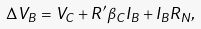Convert formula to latex. <formula><loc_0><loc_0><loc_500><loc_500>\Delta V _ { B } = V _ { C } + R ^ { \prime } \beta _ { C } I _ { B } + I _ { B } R _ { N } ,</formula> 